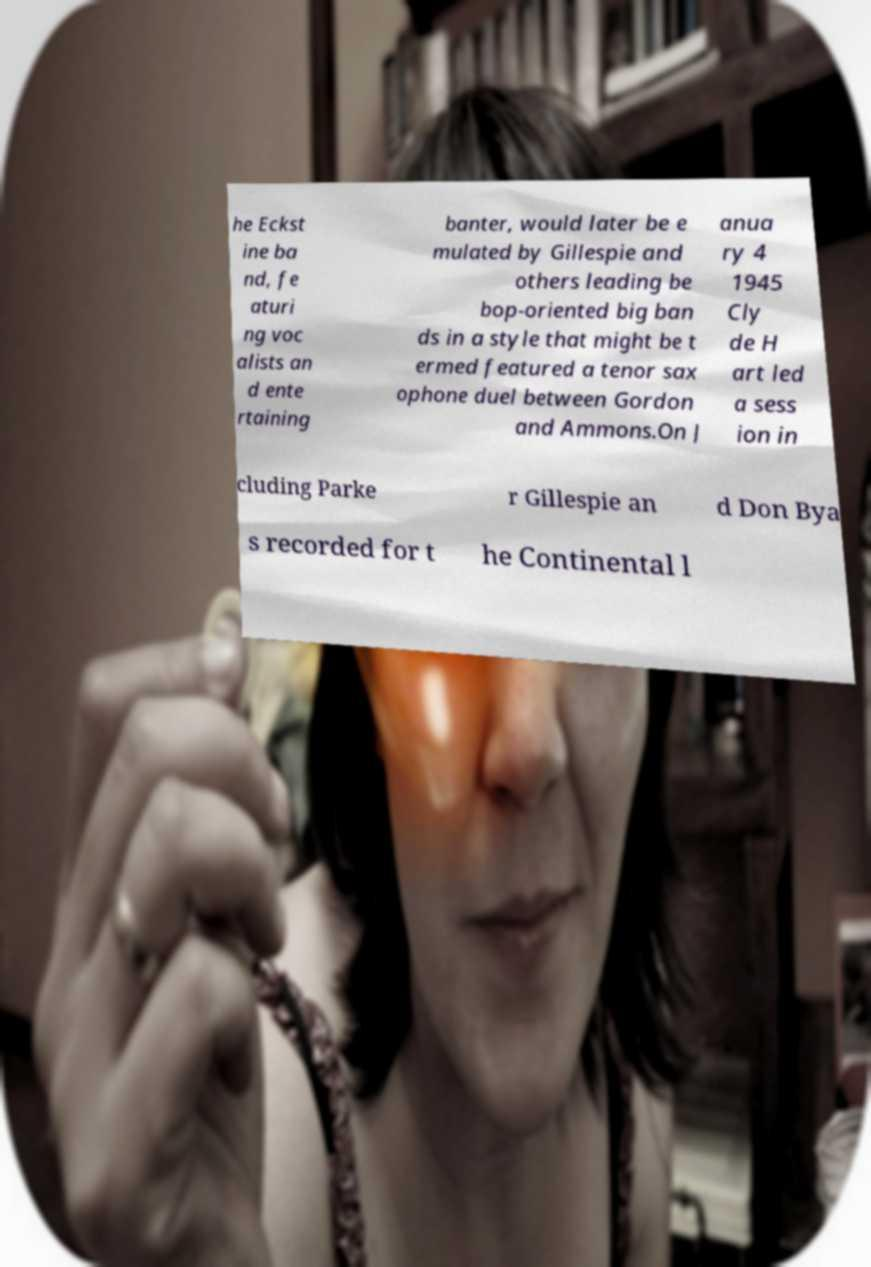Could you assist in decoding the text presented in this image and type it out clearly? he Eckst ine ba nd, fe aturi ng voc alists an d ente rtaining banter, would later be e mulated by Gillespie and others leading be bop-oriented big ban ds in a style that might be t ermed featured a tenor sax ophone duel between Gordon and Ammons.On J anua ry 4 1945 Cly de H art led a sess ion in cluding Parke r Gillespie an d Don Bya s recorded for t he Continental l 